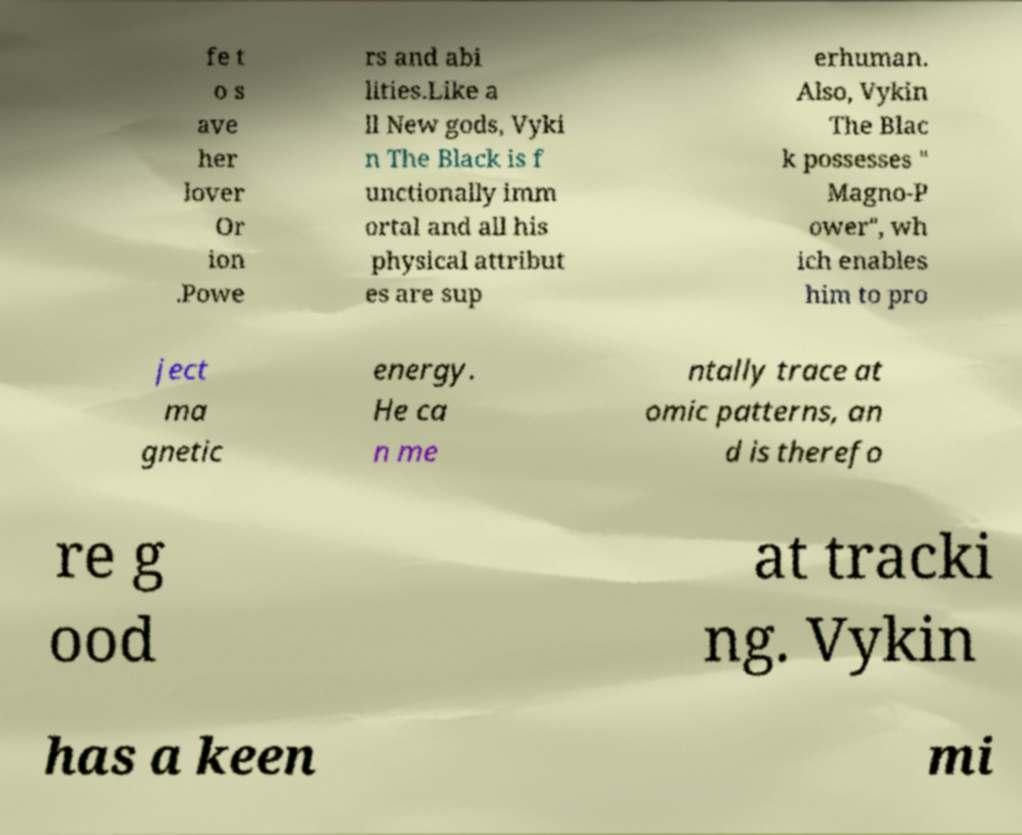What messages or text are displayed in this image? I need them in a readable, typed format. fe t o s ave her lover Or ion .Powe rs and abi lities.Like a ll New gods, Vyki n The Black is f unctionally imm ortal and all his physical attribut es are sup erhuman. Also, Vykin The Blac k possesses " Magno-P ower", wh ich enables him to pro ject ma gnetic energy. He ca n me ntally trace at omic patterns, an d is therefo re g ood at tracki ng. Vykin has a keen mi 